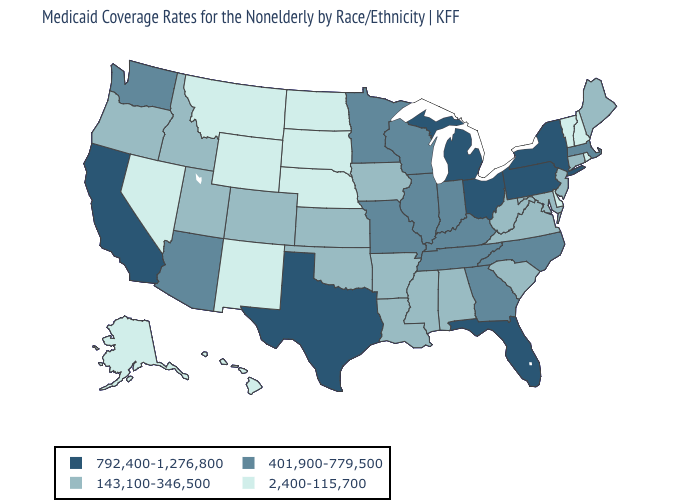Does Vermont have the highest value in the Northeast?
Concise answer only. No. Among the states that border Virginia , does North Carolina have the lowest value?
Keep it brief. No. Name the states that have a value in the range 792,400-1,276,800?
Quick response, please. California, Florida, Michigan, New York, Ohio, Pennsylvania, Texas. What is the value of Wyoming?
Answer briefly. 2,400-115,700. Which states hav the highest value in the South?
Write a very short answer. Florida, Texas. What is the highest value in the Northeast ?
Write a very short answer. 792,400-1,276,800. Among the states that border Virginia , which have the highest value?
Write a very short answer. Kentucky, North Carolina, Tennessee. Is the legend a continuous bar?
Write a very short answer. No. Does Delaware have the lowest value in the South?
Concise answer only. Yes. Does Alaska have a lower value than Pennsylvania?
Quick response, please. Yes. What is the value of West Virginia?
Concise answer only. 143,100-346,500. Name the states that have a value in the range 401,900-779,500?
Keep it brief. Arizona, Georgia, Illinois, Indiana, Kentucky, Massachusetts, Minnesota, Missouri, North Carolina, Tennessee, Washington, Wisconsin. What is the lowest value in states that border Pennsylvania?
Concise answer only. 2,400-115,700. Among the states that border Oklahoma , does Colorado have the highest value?
Give a very brief answer. No. 